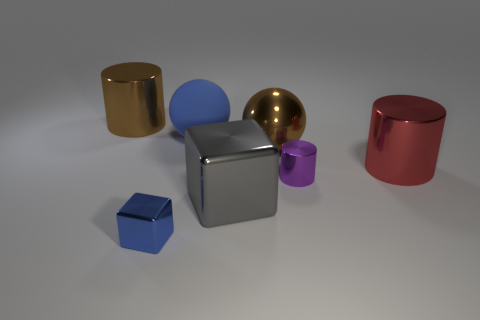There is a object that is in front of the big block; what is its size?
Your answer should be very brief. Small. There is a big brown object that is on the right side of the blue matte thing; is it the same shape as the gray shiny thing?
Ensure brevity in your answer.  No. There is another thing that is the same shape as the small blue thing; what is it made of?
Offer a very short reply. Metal. Is there any other thing that has the same size as the purple metal cylinder?
Ensure brevity in your answer.  Yes. Is there a big metallic block?
Make the answer very short. Yes. The large cylinder that is to the left of the big sphere in front of the sphere behind the metal sphere is made of what material?
Your response must be concise. Metal. Does the red shiny thing have the same shape as the brown thing that is on the right side of the blue matte sphere?
Offer a very short reply. No. How many gray shiny objects have the same shape as the red shiny object?
Your answer should be very brief. 0. What is the shape of the big red metallic thing?
Your answer should be very brief. Cylinder. There is a cylinder that is in front of the large metallic cylinder to the right of the big brown sphere; how big is it?
Provide a short and direct response. Small. 